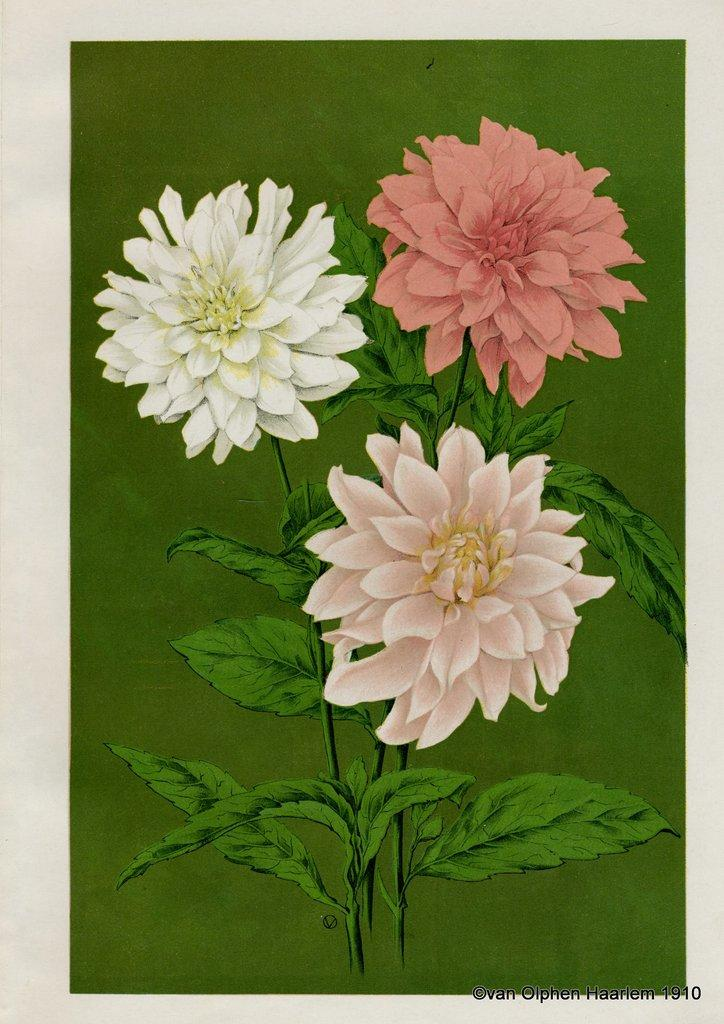What is depicted in the painting in the image? There is a painting of a plant with flowers in the image. Can you describe any additional features of the image? There is a watermark on the image. How many cows can be seen grazing in the field in the image? There are no cows or fields present in the image; it features a painting of a plant with flowers and a watermark. What type of ray is visible in the image? There is no ray present in the image. 